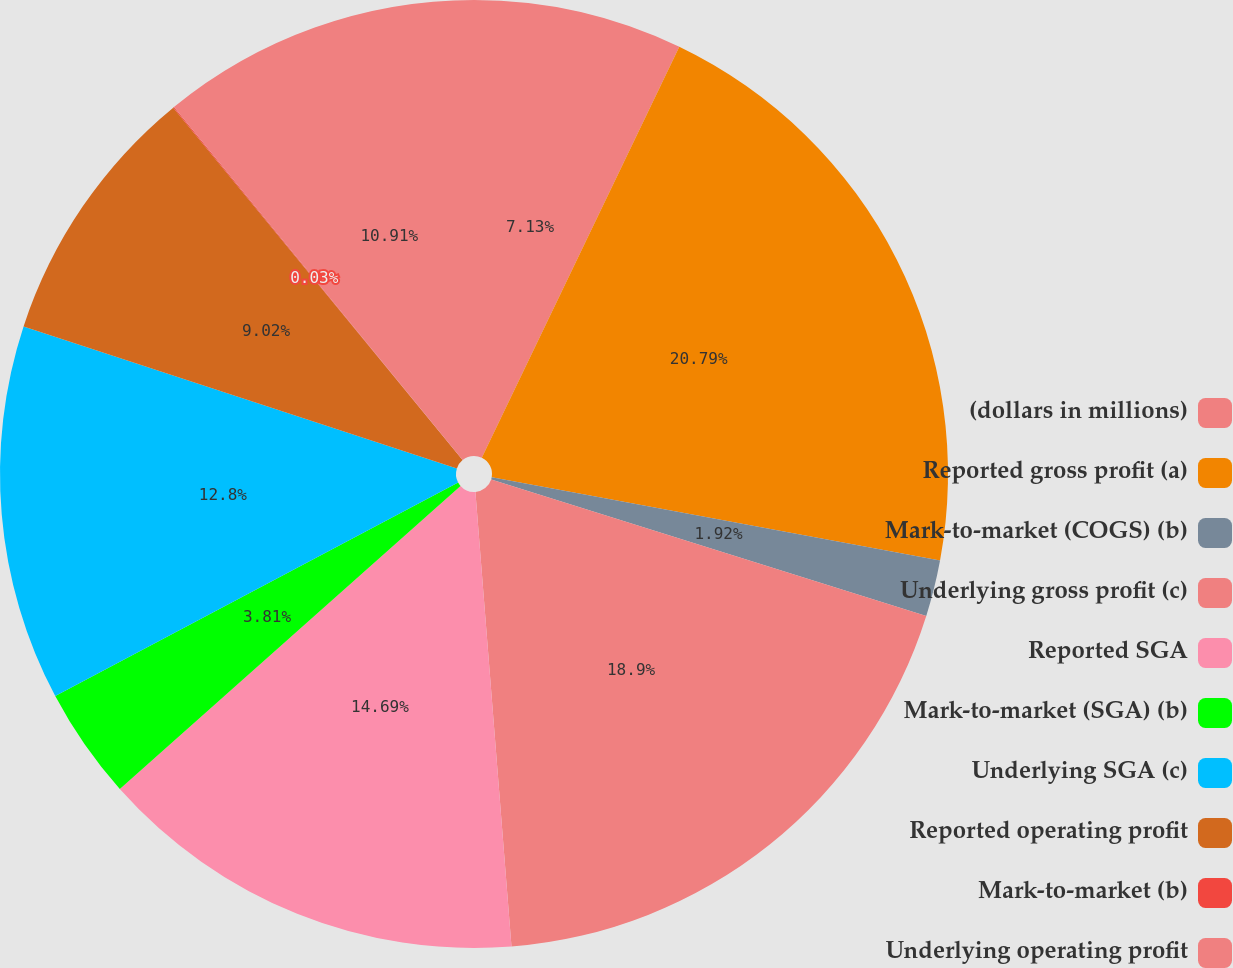Convert chart to OTSL. <chart><loc_0><loc_0><loc_500><loc_500><pie_chart><fcel>(dollars in millions)<fcel>Reported gross profit (a)<fcel>Mark-to-market (COGS) (b)<fcel>Underlying gross profit (c)<fcel>Reported SGA<fcel>Mark-to-market (SGA) (b)<fcel>Underlying SGA (c)<fcel>Reported operating profit<fcel>Mark-to-market (b)<fcel>Underlying operating profit<nl><fcel>7.13%<fcel>20.79%<fcel>1.92%<fcel>18.9%<fcel>14.69%<fcel>3.81%<fcel>12.8%<fcel>9.02%<fcel>0.03%<fcel>10.91%<nl></chart> 